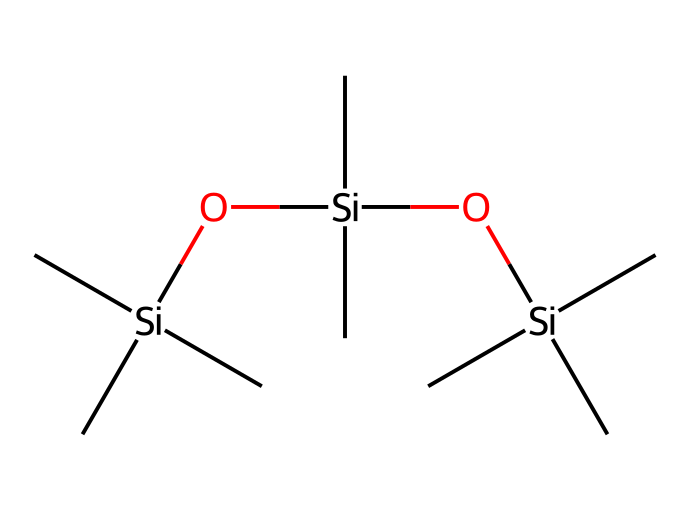What is the core structure of this chemical? The core structure consists of alternating silicon and oxygen atoms, which is characteristic of siloxane chemistry. In this SMILES representation, this is indicated by the repeating "O[Si]" pattern.
Answer: siloxane How many silicon atoms are present? By analyzing the SMILES representation, we can count the occurrences of "Si". There are three "Si" atoms visible in the total composition of the chemical.
Answer: 3 What functional groups are present in this compound? The compound exhibits siloxane (Si-O) linkages and includes alkyl groups (specifically methyl groups) as indicated by "C" without any functional groups such as alcohols or acids.
Answer: siloxane and alkyl What property does the presence of siloxane clusters impart? Siloxane clusters significantly contribute to the water-repellent characteristics of the compound, which is due to the hydrophobic methyl groups that surround the siloxane backbone.
Answer: water-repellent Count the total number of oxygen atoms in the structure. In the provided SMILES, the "O" symbols represent the oxygen atoms interconnected with the silicon atoms, and there are two "O" symbols present.
Answer: 2 